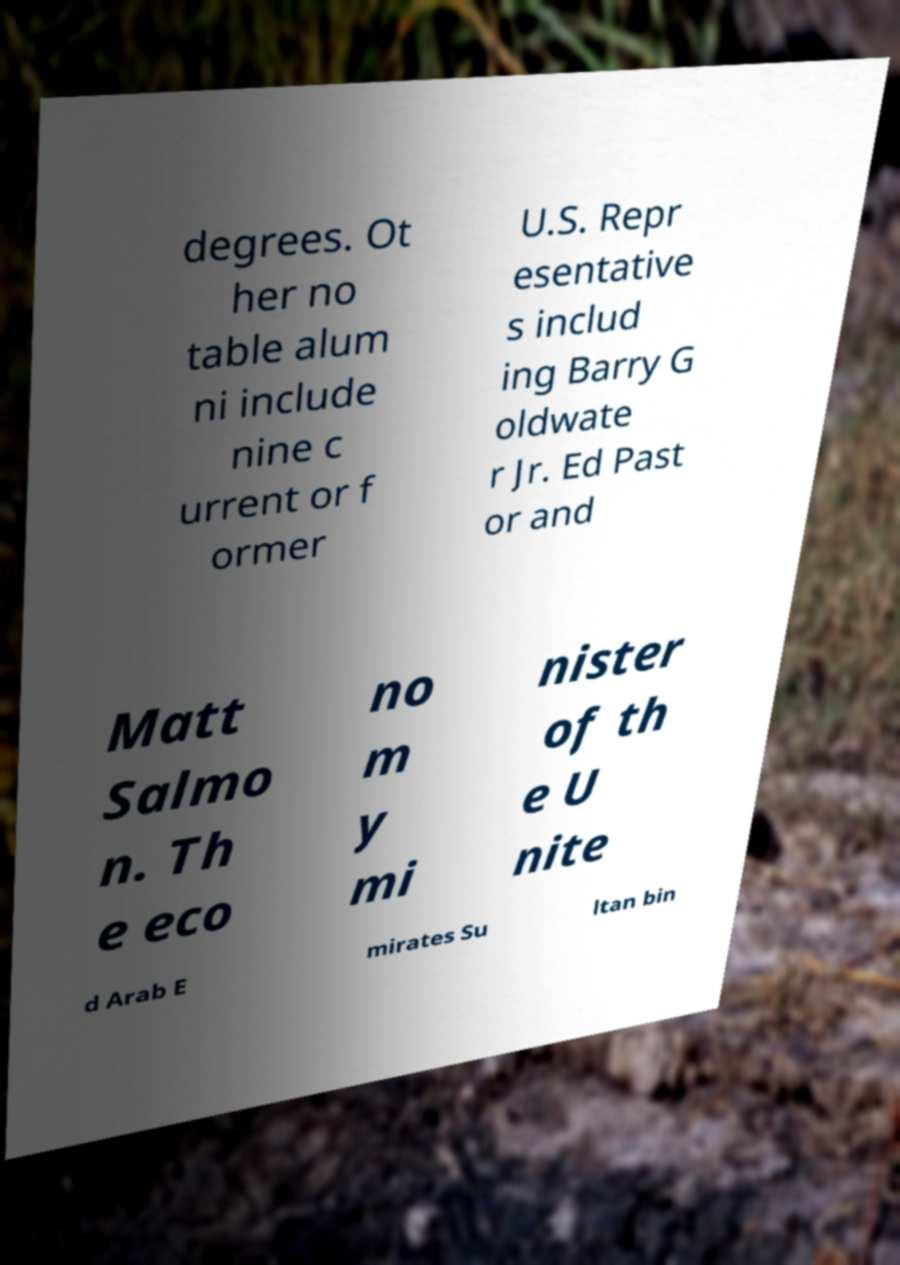Could you assist in decoding the text presented in this image and type it out clearly? degrees. Ot her no table alum ni include nine c urrent or f ormer U.S. Repr esentative s includ ing Barry G oldwate r Jr. Ed Past or and Matt Salmo n. Th e eco no m y mi nister of th e U nite d Arab E mirates Su ltan bin 